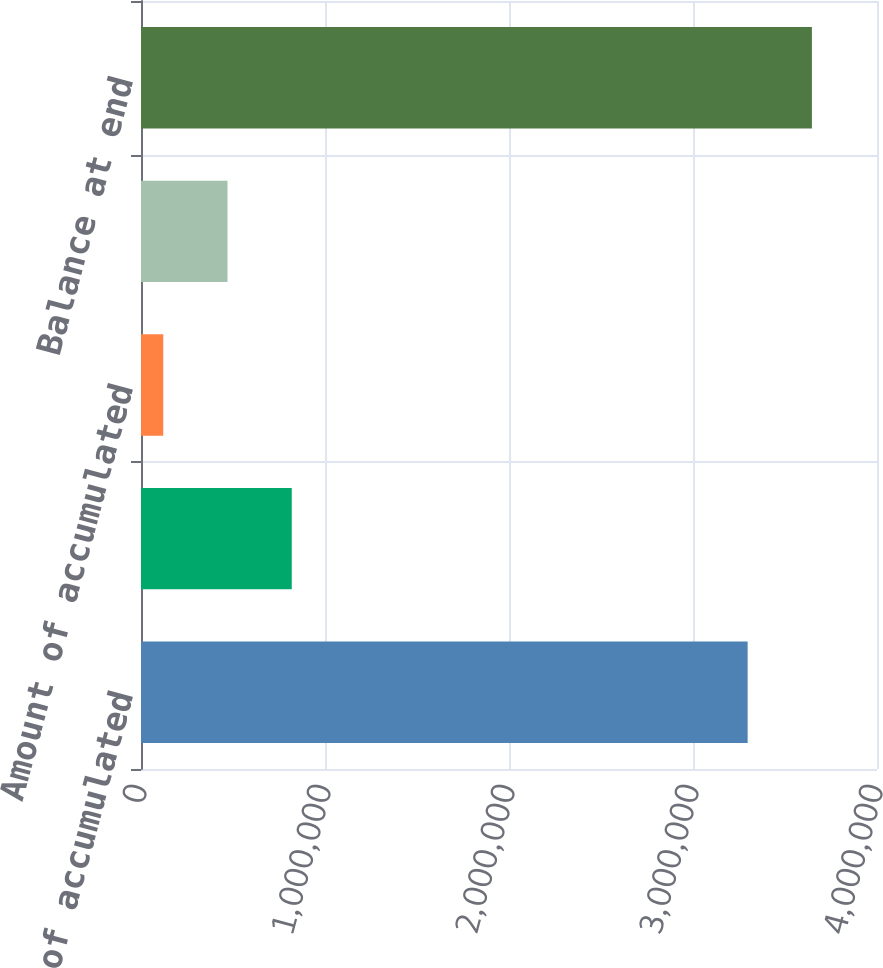Convert chart. <chart><loc_0><loc_0><loc_500><loc_500><bar_chart><fcel>Gross amount of accumulated<fcel>Deductions during period<fcel>Amount of accumulated<fcel>Total deductions<fcel>Balance at end<nl><fcel>3.29703e+06<fcel>819334<fcel>120898<fcel>470116<fcel>3.64625e+06<nl></chart> 